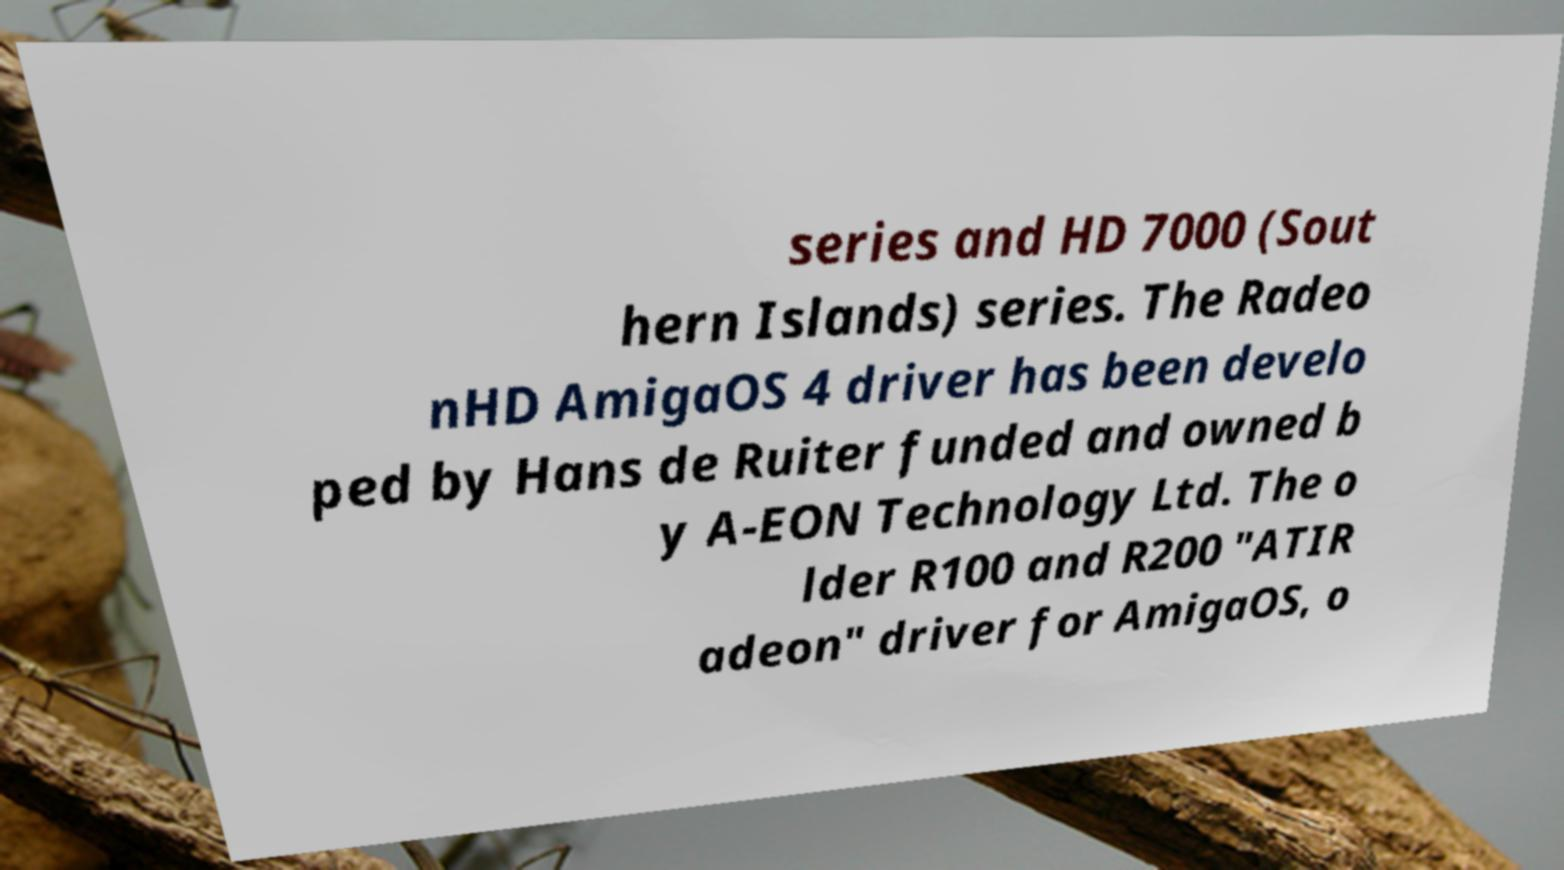Can you accurately transcribe the text from the provided image for me? series and HD 7000 (Sout hern Islands) series. The Radeo nHD AmigaOS 4 driver has been develo ped by Hans de Ruiter funded and owned b y A-EON Technology Ltd. The o lder R100 and R200 "ATIR adeon" driver for AmigaOS, o 